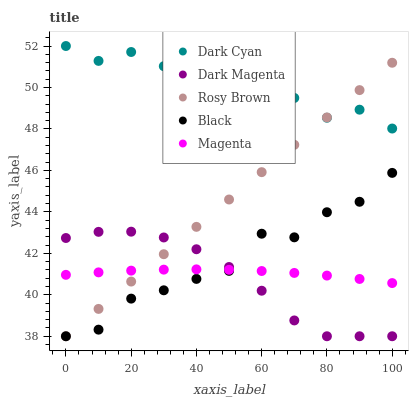Does Dark Magenta have the minimum area under the curve?
Answer yes or no. Yes. Does Dark Cyan have the maximum area under the curve?
Answer yes or no. Yes. Does Magenta have the minimum area under the curve?
Answer yes or no. No. Does Magenta have the maximum area under the curve?
Answer yes or no. No. Is Rosy Brown the smoothest?
Answer yes or no. Yes. Is Black the roughest?
Answer yes or no. Yes. Is Magenta the smoothest?
Answer yes or no. No. Is Magenta the roughest?
Answer yes or no. No. Does Rosy Brown have the lowest value?
Answer yes or no. Yes. Does Magenta have the lowest value?
Answer yes or no. No. Does Dark Cyan have the highest value?
Answer yes or no. Yes. Does Rosy Brown have the highest value?
Answer yes or no. No. Is Black less than Dark Cyan?
Answer yes or no. Yes. Is Dark Cyan greater than Dark Magenta?
Answer yes or no. Yes. Does Magenta intersect Rosy Brown?
Answer yes or no. Yes. Is Magenta less than Rosy Brown?
Answer yes or no. No. Is Magenta greater than Rosy Brown?
Answer yes or no. No. Does Black intersect Dark Cyan?
Answer yes or no. No. 